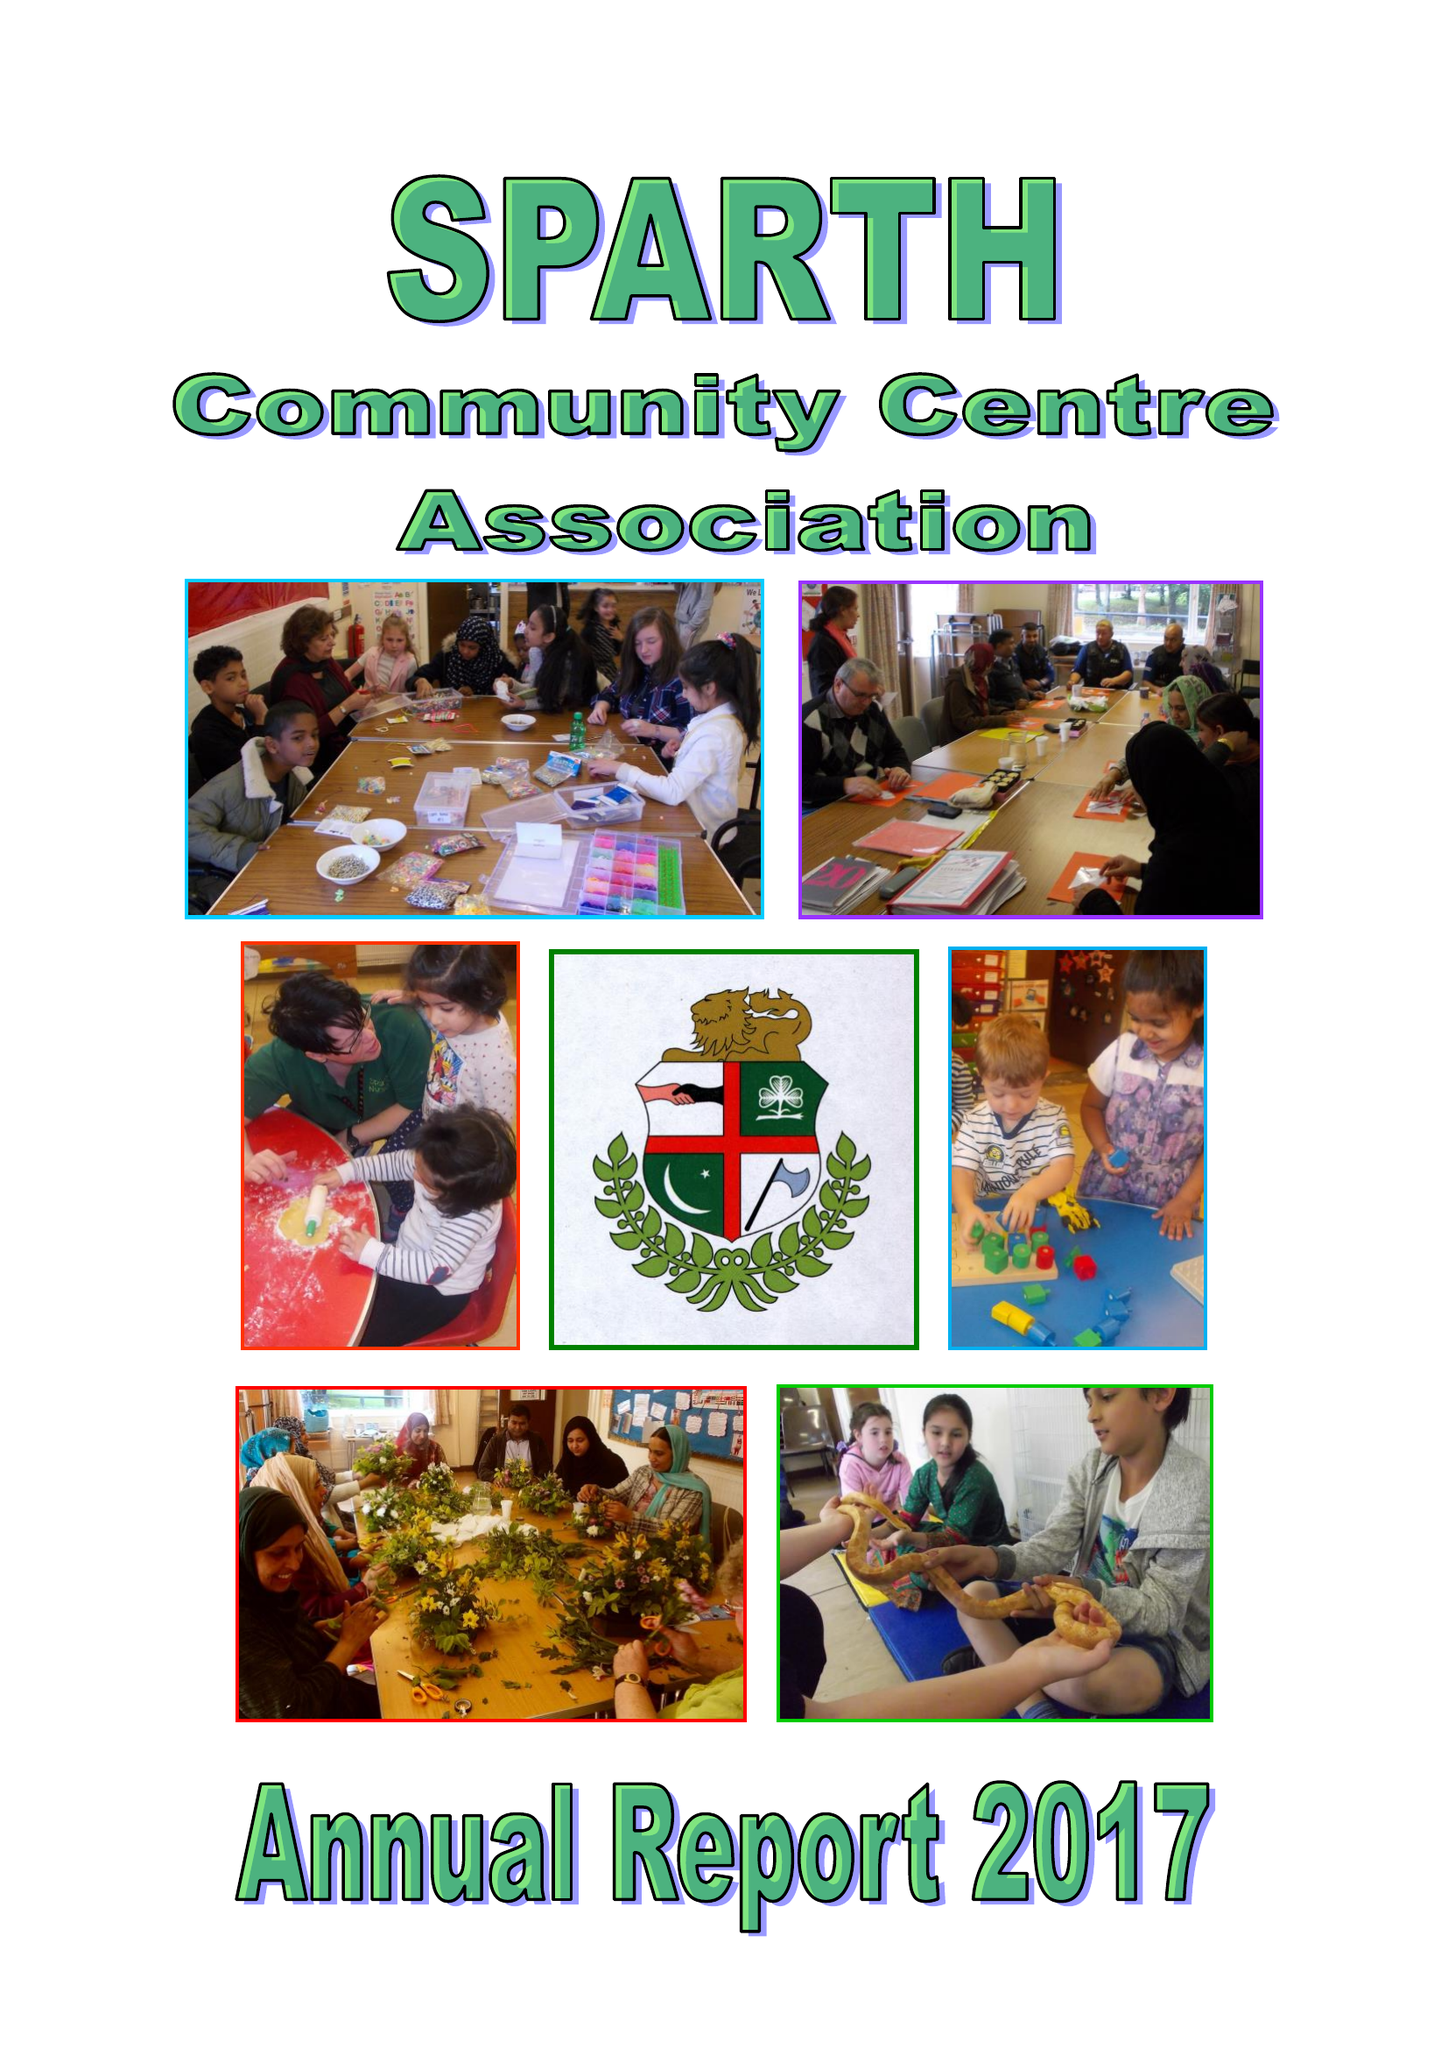What is the value for the charity_number?
Answer the question using a single word or phrase. 1076292 